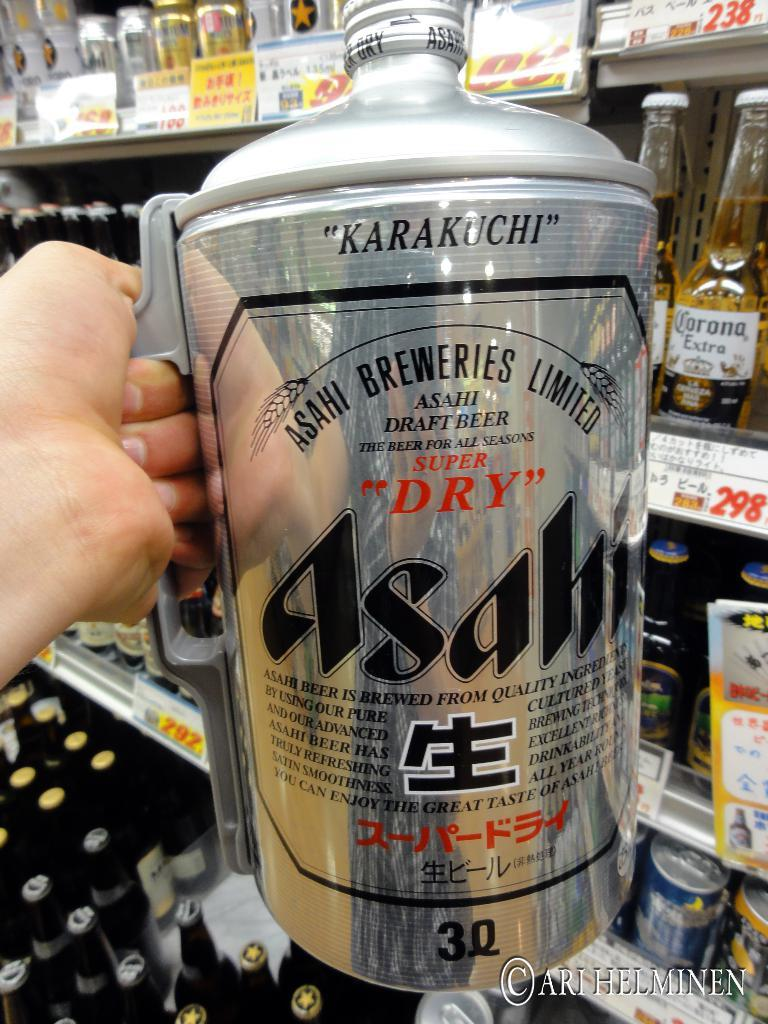Provide a one-sentence caption for the provided image. A mug from the Asahi Breweries Limited company is available in a 3Q size. 